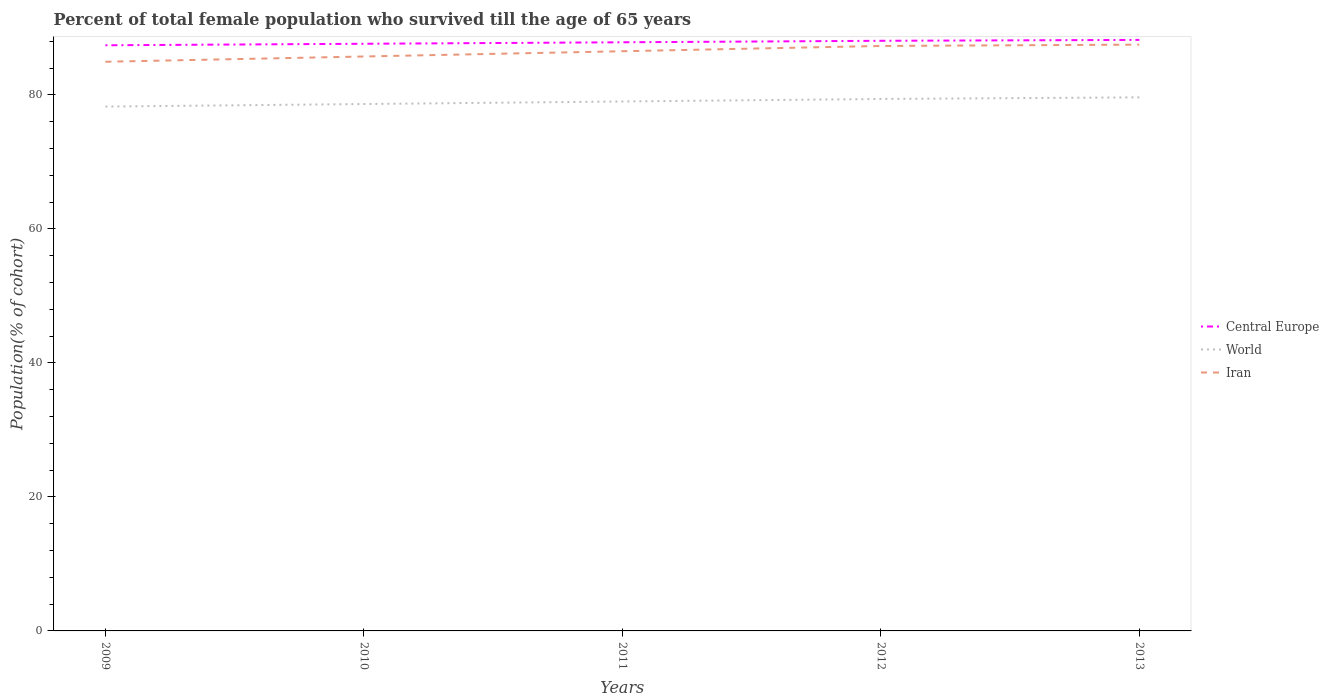How many different coloured lines are there?
Offer a terse response. 3. Does the line corresponding to Central Europe intersect with the line corresponding to Iran?
Keep it short and to the point. No. Is the number of lines equal to the number of legend labels?
Keep it short and to the point. Yes. Across all years, what is the maximum percentage of total female population who survived till the age of 65 years in Central Europe?
Your response must be concise. 87.39. In which year was the percentage of total female population who survived till the age of 65 years in Iran maximum?
Offer a terse response. 2009. What is the total percentage of total female population who survived till the age of 65 years in World in the graph?
Give a very brief answer. -1.38. What is the difference between the highest and the second highest percentage of total female population who survived till the age of 65 years in World?
Offer a very short reply. 1.38. What is the difference between the highest and the lowest percentage of total female population who survived till the age of 65 years in World?
Ensure brevity in your answer.  3. Is the percentage of total female population who survived till the age of 65 years in World strictly greater than the percentage of total female population who survived till the age of 65 years in Central Europe over the years?
Ensure brevity in your answer.  Yes. How many lines are there?
Your response must be concise. 3. How many years are there in the graph?
Offer a very short reply. 5. What is the difference between two consecutive major ticks on the Y-axis?
Your response must be concise. 20. Does the graph contain any zero values?
Ensure brevity in your answer.  No. How are the legend labels stacked?
Make the answer very short. Vertical. What is the title of the graph?
Provide a succinct answer. Percent of total female population who survived till the age of 65 years. Does "Other small states" appear as one of the legend labels in the graph?
Your answer should be very brief. No. What is the label or title of the Y-axis?
Ensure brevity in your answer.  Population(% of cohort). What is the Population(% of cohort) in Central Europe in 2009?
Your answer should be compact. 87.39. What is the Population(% of cohort) in World in 2009?
Provide a succinct answer. 78.24. What is the Population(% of cohort) in Iran in 2009?
Your answer should be compact. 84.93. What is the Population(% of cohort) in Central Europe in 2010?
Ensure brevity in your answer.  87.62. What is the Population(% of cohort) of World in 2010?
Provide a short and direct response. 78.62. What is the Population(% of cohort) in Iran in 2010?
Offer a terse response. 85.72. What is the Population(% of cohort) in Central Europe in 2011?
Keep it short and to the point. 87.84. What is the Population(% of cohort) of World in 2011?
Provide a short and direct response. 79. What is the Population(% of cohort) in Iran in 2011?
Offer a terse response. 86.5. What is the Population(% of cohort) in Central Europe in 2012?
Provide a short and direct response. 88.06. What is the Population(% of cohort) of World in 2012?
Your response must be concise. 79.38. What is the Population(% of cohort) of Iran in 2012?
Keep it short and to the point. 87.29. What is the Population(% of cohort) in Central Europe in 2013?
Offer a very short reply. 88.19. What is the Population(% of cohort) in World in 2013?
Ensure brevity in your answer.  79.62. What is the Population(% of cohort) in Iran in 2013?
Give a very brief answer. 87.49. Across all years, what is the maximum Population(% of cohort) of Central Europe?
Your answer should be very brief. 88.19. Across all years, what is the maximum Population(% of cohort) of World?
Your response must be concise. 79.62. Across all years, what is the maximum Population(% of cohort) of Iran?
Provide a succinct answer. 87.49. Across all years, what is the minimum Population(% of cohort) of Central Europe?
Your answer should be very brief. 87.39. Across all years, what is the minimum Population(% of cohort) of World?
Give a very brief answer. 78.24. Across all years, what is the minimum Population(% of cohort) of Iran?
Keep it short and to the point. 84.93. What is the total Population(% of cohort) in Central Europe in the graph?
Provide a succinct answer. 439.1. What is the total Population(% of cohort) in World in the graph?
Your response must be concise. 394.87. What is the total Population(% of cohort) of Iran in the graph?
Your response must be concise. 431.93. What is the difference between the Population(% of cohort) in Central Europe in 2009 and that in 2010?
Give a very brief answer. -0.23. What is the difference between the Population(% of cohort) of World in 2009 and that in 2010?
Your answer should be compact. -0.38. What is the difference between the Population(% of cohort) of Iran in 2009 and that in 2010?
Your answer should be compact. -0.79. What is the difference between the Population(% of cohort) of Central Europe in 2009 and that in 2011?
Your answer should be very brief. -0.45. What is the difference between the Population(% of cohort) in World in 2009 and that in 2011?
Offer a terse response. -0.76. What is the difference between the Population(% of cohort) in Iran in 2009 and that in 2011?
Offer a terse response. -1.57. What is the difference between the Population(% of cohort) in Central Europe in 2009 and that in 2012?
Your response must be concise. -0.67. What is the difference between the Population(% of cohort) of World in 2009 and that in 2012?
Your response must be concise. -1.14. What is the difference between the Population(% of cohort) of Iran in 2009 and that in 2012?
Your answer should be very brief. -2.36. What is the difference between the Population(% of cohort) of Central Europe in 2009 and that in 2013?
Provide a succinct answer. -0.8. What is the difference between the Population(% of cohort) of World in 2009 and that in 2013?
Provide a short and direct response. -1.38. What is the difference between the Population(% of cohort) of Iran in 2009 and that in 2013?
Provide a succinct answer. -2.56. What is the difference between the Population(% of cohort) in Central Europe in 2010 and that in 2011?
Make the answer very short. -0.22. What is the difference between the Population(% of cohort) in World in 2010 and that in 2011?
Provide a succinct answer. -0.38. What is the difference between the Population(% of cohort) in Iran in 2010 and that in 2011?
Your answer should be compact. -0.79. What is the difference between the Population(% of cohort) of Central Europe in 2010 and that in 2012?
Ensure brevity in your answer.  -0.44. What is the difference between the Population(% of cohort) in World in 2010 and that in 2012?
Offer a terse response. -0.76. What is the difference between the Population(% of cohort) of Iran in 2010 and that in 2012?
Provide a short and direct response. -1.57. What is the difference between the Population(% of cohort) in Central Europe in 2010 and that in 2013?
Offer a terse response. -0.58. What is the difference between the Population(% of cohort) of World in 2010 and that in 2013?
Provide a short and direct response. -1. What is the difference between the Population(% of cohort) of Iran in 2010 and that in 2013?
Keep it short and to the point. -1.77. What is the difference between the Population(% of cohort) in Central Europe in 2011 and that in 2012?
Offer a very short reply. -0.22. What is the difference between the Population(% of cohort) in World in 2011 and that in 2012?
Offer a very short reply. -0.37. What is the difference between the Population(% of cohort) of Iran in 2011 and that in 2012?
Provide a short and direct response. -0.79. What is the difference between the Population(% of cohort) in Central Europe in 2011 and that in 2013?
Give a very brief answer. -0.35. What is the difference between the Population(% of cohort) of World in 2011 and that in 2013?
Make the answer very short. -0.62. What is the difference between the Population(% of cohort) of Iran in 2011 and that in 2013?
Provide a succinct answer. -0.99. What is the difference between the Population(% of cohort) of Central Europe in 2012 and that in 2013?
Offer a very short reply. -0.13. What is the difference between the Population(% of cohort) of World in 2012 and that in 2013?
Make the answer very short. -0.24. What is the difference between the Population(% of cohort) of Iran in 2012 and that in 2013?
Give a very brief answer. -0.2. What is the difference between the Population(% of cohort) of Central Europe in 2009 and the Population(% of cohort) of World in 2010?
Keep it short and to the point. 8.77. What is the difference between the Population(% of cohort) in Central Europe in 2009 and the Population(% of cohort) in Iran in 2010?
Your answer should be very brief. 1.67. What is the difference between the Population(% of cohort) of World in 2009 and the Population(% of cohort) of Iran in 2010?
Offer a very short reply. -7.47. What is the difference between the Population(% of cohort) in Central Europe in 2009 and the Population(% of cohort) in World in 2011?
Make the answer very short. 8.39. What is the difference between the Population(% of cohort) of Central Europe in 2009 and the Population(% of cohort) of Iran in 2011?
Offer a terse response. 0.89. What is the difference between the Population(% of cohort) in World in 2009 and the Population(% of cohort) in Iran in 2011?
Your answer should be compact. -8.26. What is the difference between the Population(% of cohort) in Central Europe in 2009 and the Population(% of cohort) in World in 2012?
Your answer should be compact. 8.01. What is the difference between the Population(% of cohort) of Central Europe in 2009 and the Population(% of cohort) of Iran in 2012?
Provide a succinct answer. 0.1. What is the difference between the Population(% of cohort) of World in 2009 and the Population(% of cohort) of Iran in 2012?
Your answer should be compact. -9.04. What is the difference between the Population(% of cohort) in Central Europe in 2009 and the Population(% of cohort) in World in 2013?
Provide a short and direct response. 7.77. What is the difference between the Population(% of cohort) of Central Europe in 2009 and the Population(% of cohort) of Iran in 2013?
Make the answer very short. -0.1. What is the difference between the Population(% of cohort) in World in 2009 and the Population(% of cohort) in Iran in 2013?
Ensure brevity in your answer.  -9.24. What is the difference between the Population(% of cohort) in Central Europe in 2010 and the Population(% of cohort) in World in 2011?
Your answer should be very brief. 8.61. What is the difference between the Population(% of cohort) in Central Europe in 2010 and the Population(% of cohort) in Iran in 2011?
Keep it short and to the point. 1.11. What is the difference between the Population(% of cohort) of World in 2010 and the Population(% of cohort) of Iran in 2011?
Provide a succinct answer. -7.88. What is the difference between the Population(% of cohort) of Central Europe in 2010 and the Population(% of cohort) of World in 2012?
Ensure brevity in your answer.  8.24. What is the difference between the Population(% of cohort) in Central Europe in 2010 and the Population(% of cohort) in Iran in 2012?
Ensure brevity in your answer.  0.33. What is the difference between the Population(% of cohort) in World in 2010 and the Population(% of cohort) in Iran in 2012?
Offer a terse response. -8.66. What is the difference between the Population(% of cohort) of Central Europe in 2010 and the Population(% of cohort) of World in 2013?
Offer a very short reply. 8. What is the difference between the Population(% of cohort) of Central Europe in 2010 and the Population(% of cohort) of Iran in 2013?
Your response must be concise. 0.13. What is the difference between the Population(% of cohort) in World in 2010 and the Population(% of cohort) in Iran in 2013?
Provide a succinct answer. -8.86. What is the difference between the Population(% of cohort) in Central Europe in 2011 and the Population(% of cohort) in World in 2012?
Offer a very short reply. 8.46. What is the difference between the Population(% of cohort) of Central Europe in 2011 and the Population(% of cohort) of Iran in 2012?
Provide a short and direct response. 0.55. What is the difference between the Population(% of cohort) in World in 2011 and the Population(% of cohort) in Iran in 2012?
Ensure brevity in your answer.  -8.28. What is the difference between the Population(% of cohort) in Central Europe in 2011 and the Population(% of cohort) in World in 2013?
Offer a terse response. 8.22. What is the difference between the Population(% of cohort) of Central Europe in 2011 and the Population(% of cohort) of Iran in 2013?
Your answer should be compact. 0.35. What is the difference between the Population(% of cohort) in World in 2011 and the Population(% of cohort) in Iran in 2013?
Make the answer very short. -8.48. What is the difference between the Population(% of cohort) of Central Europe in 2012 and the Population(% of cohort) of World in 2013?
Your response must be concise. 8.44. What is the difference between the Population(% of cohort) in Central Europe in 2012 and the Population(% of cohort) in Iran in 2013?
Give a very brief answer. 0.57. What is the difference between the Population(% of cohort) in World in 2012 and the Population(% of cohort) in Iran in 2013?
Provide a short and direct response. -8.11. What is the average Population(% of cohort) in Central Europe per year?
Make the answer very short. 87.82. What is the average Population(% of cohort) of World per year?
Provide a succinct answer. 78.97. What is the average Population(% of cohort) in Iran per year?
Your answer should be very brief. 86.39. In the year 2009, what is the difference between the Population(% of cohort) of Central Europe and Population(% of cohort) of World?
Provide a short and direct response. 9.15. In the year 2009, what is the difference between the Population(% of cohort) in Central Europe and Population(% of cohort) in Iran?
Offer a very short reply. 2.46. In the year 2009, what is the difference between the Population(% of cohort) of World and Population(% of cohort) of Iran?
Make the answer very short. -6.69. In the year 2010, what is the difference between the Population(% of cohort) of Central Europe and Population(% of cohort) of World?
Offer a terse response. 8.99. In the year 2010, what is the difference between the Population(% of cohort) of Central Europe and Population(% of cohort) of Iran?
Your answer should be very brief. 1.9. In the year 2010, what is the difference between the Population(% of cohort) of World and Population(% of cohort) of Iran?
Your response must be concise. -7.09. In the year 2011, what is the difference between the Population(% of cohort) of Central Europe and Population(% of cohort) of World?
Provide a short and direct response. 8.83. In the year 2011, what is the difference between the Population(% of cohort) in Central Europe and Population(% of cohort) in Iran?
Your response must be concise. 1.33. In the year 2011, what is the difference between the Population(% of cohort) of World and Population(% of cohort) of Iran?
Give a very brief answer. -7.5. In the year 2012, what is the difference between the Population(% of cohort) in Central Europe and Population(% of cohort) in World?
Offer a very short reply. 8.68. In the year 2012, what is the difference between the Population(% of cohort) of Central Europe and Population(% of cohort) of Iran?
Keep it short and to the point. 0.77. In the year 2012, what is the difference between the Population(% of cohort) in World and Population(% of cohort) in Iran?
Give a very brief answer. -7.91. In the year 2013, what is the difference between the Population(% of cohort) in Central Europe and Population(% of cohort) in World?
Offer a very short reply. 8.57. In the year 2013, what is the difference between the Population(% of cohort) of Central Europe and Population(% of cohort) of Iran?
Your answer should be very brief. 0.7. In the year 2013, what is the difference between the Population(% of cohort) of World and Population(% of cohort) of Iran?
Provide a short and direct response. -7.87. What is the ratio of the Population(% of cohort) of Central Europe in 2009 to that in 2010?
Make the answer very short. 1. What is the ratio of the Population(% of cohort) in Iran in 2009 to that in 2010?
Provide a short and direct response. 0.99. What is the ratio of the Population(% of cohort) in Central Europe in 2009 to that in 2011?
Your answer should be very brief. 0.99. What is the ratio of the Population(% of cohort) of World in 2009 to that in 2011?
Give a very brief answer. 0.99. What is the ratio of the Population(% of cohort) of Iran in 2009 to that in 2011?
Your response must be concise. 0.98. What is the ratio of the Population(% of cohort) in Central Europe in 2009 to that in 2012?
Provide a short and direct response. 0.99. What is the ratio of the Population(% of cohort) of World in 2009 to that in 2012?
Ensure brevity in your answer.  0.99. What is the ratio of the Population(% of cohort) in Central Europe in 2009 to that in 2013?
Make the answer very short. 0.99. What is the ratio of the Population(% of cohort) in World in 2009 to that in 2013?
Make the answer very short. 0.98. What is the ratio of the Population(% of cohort) in Iran in 2009 to that in 2013?
Your answer should be very brief. 0.97. What is the ratio of the Population(% of cohort) of Central Europe in 2010 to that in 2011?
Your answer should be compact. 1. What is the ratio of the Population(% of cohort) in Iran in 2010 to that in 2011?
Offer a very short reply. 0.99. What is the ratio of the Population(% of cohort) in World in 2010 to that in 2013?
Offer a very short reply. 0.99. What is the ratio of the Population(% of cohort) of Iran in 2010 to that in 2013?
Give a very brief answer. 0.98. What is the ratio of the Population(% of cohort) in Central Europe in 2011 to that in 2013?
Offer a terse response. 1. What is the ratio of the Population(% of cohort) in World in 2011 to that in 2013?
Your answer should be very brief. 0.99. What is the ratio of the Population(% of cohort) of Iran in 2011 to that in 2013?
Your response must be concise. 0.99. What is the difference between the highest and the second highest Population(% of cohort) of Central Europe?
Provide a succinct answer. 0.13. What is the difference between the highest and the second highest Population(% of cohort) of World?
Provide a succinct answer. 0.24. What is the difference between the highest and the second highest Population(% of cohort) of Iran?
Make the answer very short. 0.2. What is the difference between the highest and the lowest Population(% of cohort) in Central Europe?
Make the answer very short. 0.8. What is the difference between the highest and the lowest Population(% of cohort) in World?
Provide a short and direct response. 1.38. What is the difference between the highest and the lowest Population(% of cohort) in Iran?
Offer a very short reply. 2.56. 